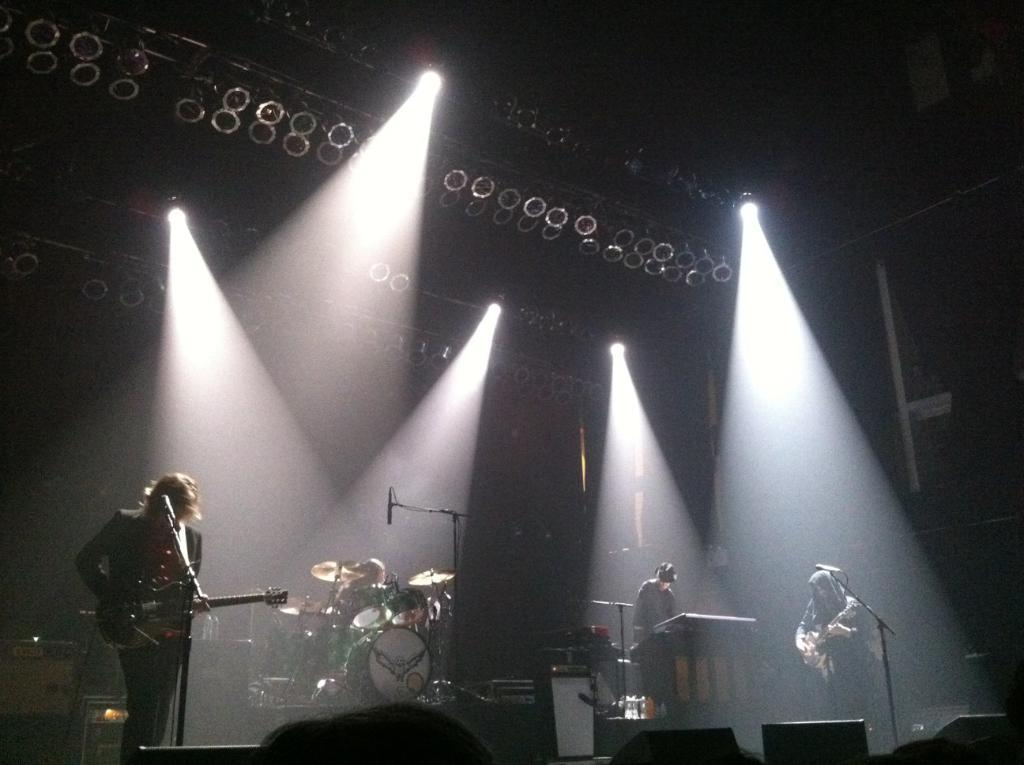What are the people in the image doing? The people in the image are holding musical instruments. Where are the people with musical instruments located? These people are on a stage. What equipment is visible in the image that might be used for amplifying sound? There are microphones (mics) in the image. What objects are present in the image that might be used for holding or displaying items? There are stands in the image. What type of lighting is visible in the image? There are lights in the image. What type of objects are present in the image that are associated with music? There are musical instruments in the image. What is the color of the background in the image? The background of the image is black. What type of leather is visible on the air in the image? There is no leather visible in the image, and there is no air present in the image. What type of room is depicted in the image? The image does not show a room; it shows people on a stage with musical instruments and equipment. 